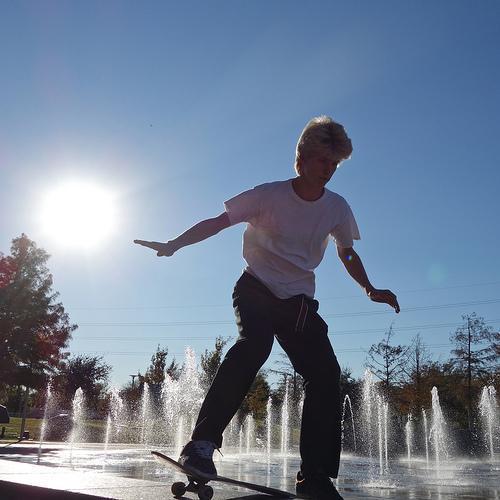How many people are in the photo?
Give a very brief answer. 1. 